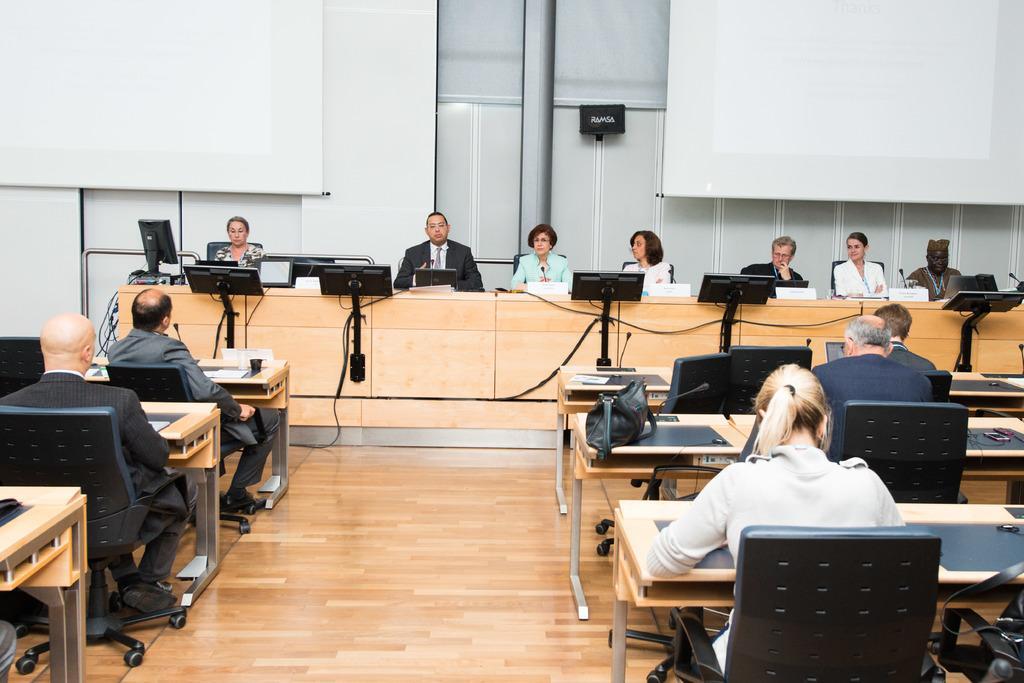Can you describe this image briefly? Here we can see few persons sitting on chairs in front of a table and on the table we can see miles and laptops. This is a floor. Here we can see few persons sitting on chairs in front of a table and on the table we can see bags and glasses. On the background we can see white colour boards. 